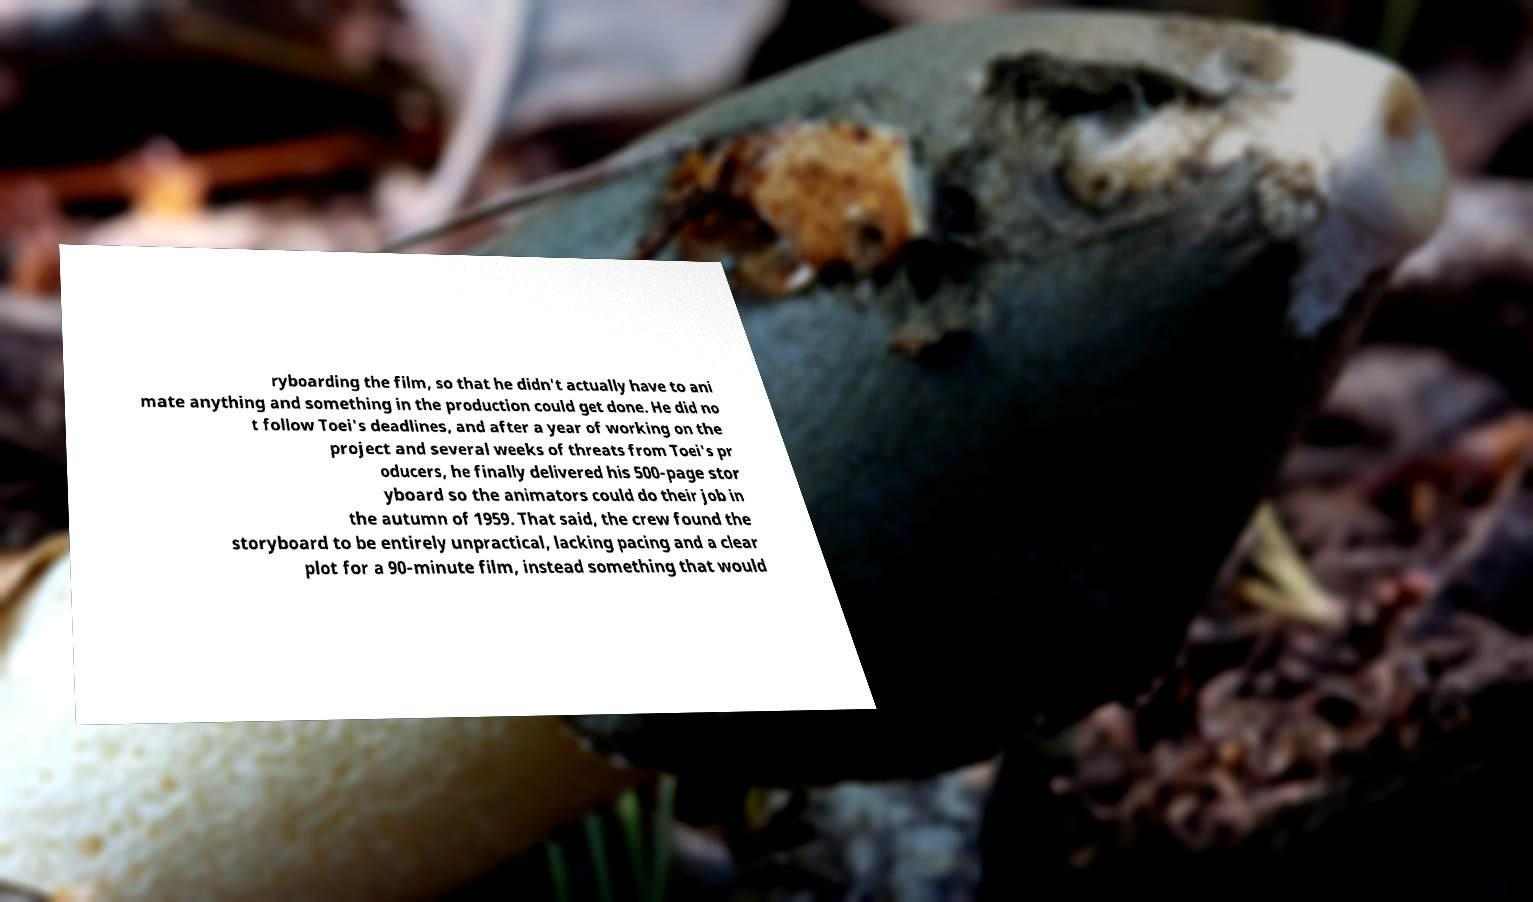Please read and relay the text visible in this image. What does it say? ryboarding the film, so that he didn't actually have to ani mate anything and something in the production could get done. He did no t follow Toei's deadlines, and after a year of working on the project and several weeks of threats from Toei's pr oducers, he finally delivered his 500-page stor yboard so the animators could do their job in the autumn of 1959. That said, the crew found the storyboard to be entirely unpractical, lacking pacing and a clear plot for a 90-minute film, instead something that would 